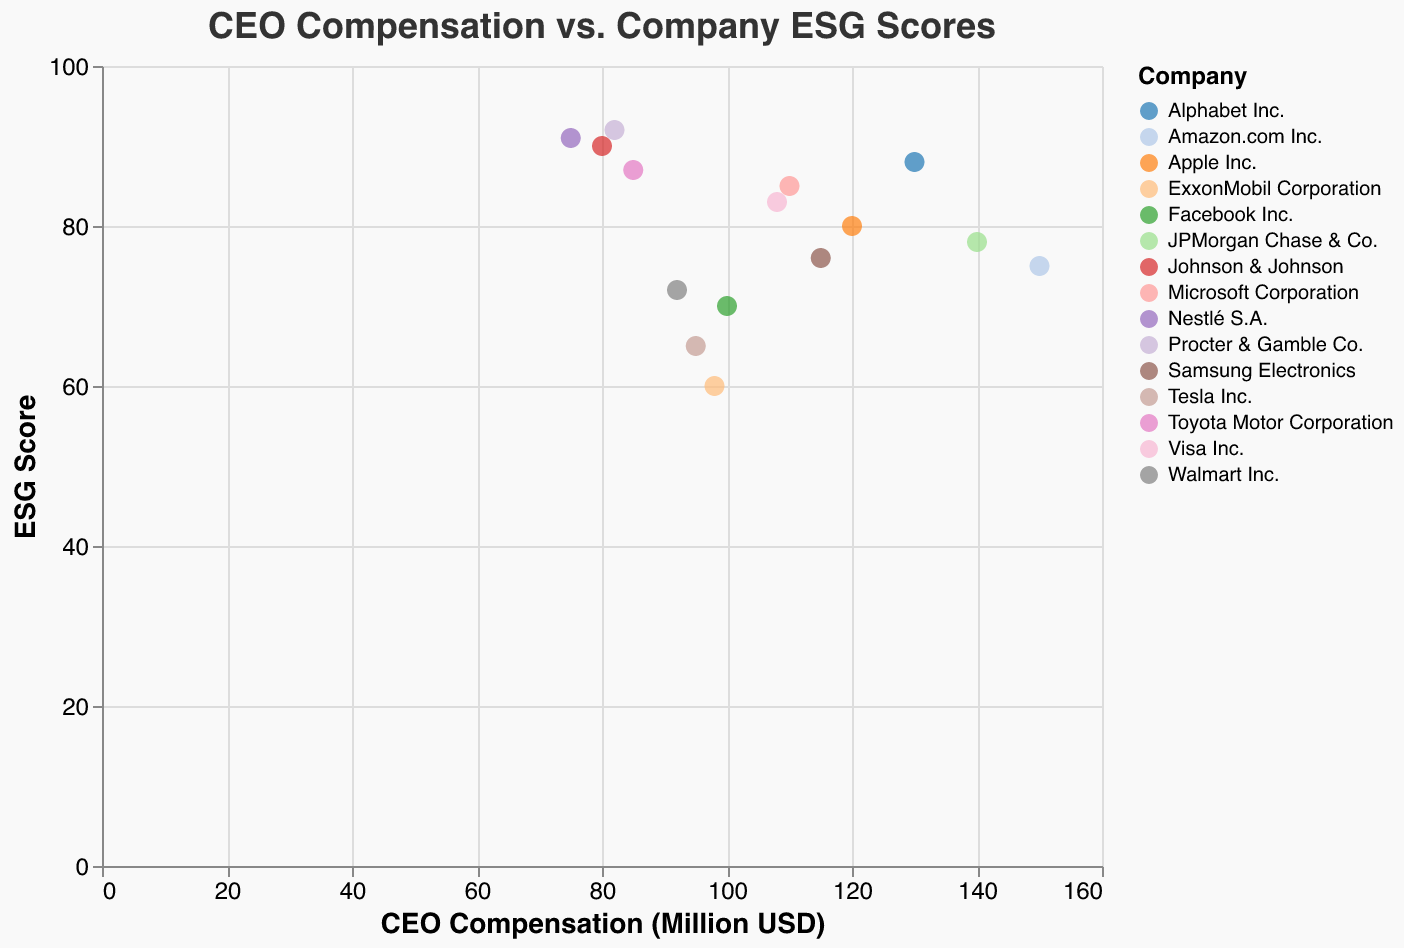What's the title of the plot? The title is usually placed prominently at the top of the plot.
Answer: CEO Compensation vs. Company ESG Scores How many companies are represented in the plot? Each point in the scatter plot represents a different company. Counting all individual points will give the number of companies.
Answer: 15 Which company has the highest CEO compensation? Look for the point farthest to the right on the x-axis, then check the corresponding company label from the tooltip or color legend.
Answer: Amazon.com Inc Which company has the highest ESG Score? Look for the point highest on the y-axis, then check the corresponding company label from the tooltip or color legend.
Answer: Procter & Gamble Co What is the ESG score of the company with the lowest CEO compensation? First, identify the point farthest left on the x-axis (Nestlé S.A.) and then find its corresponding y-axis value.
Answer: 91 What is the average ESG score of the companies with CEO compensation above 100 million USD? Identify companies with compensation above 100 million USD (Apple Inc., Microsoft Corporation, Amazon.com Inc., Alphabet Inc., JPMorgan Chase & Co., Samsung Electronics), calculate their ESG scores' sum (80 + 85 + 75 + 88 + 78 + 76 = 482), and divide by the number of these companies (6).
Answer: 80.3 Which company has a higher CEO compensation: Tesla Inc. or Toyota Motor Corporation? Compare the x-axis values for Tesla Inc. and Toyota Motor Corporation, with Tesla at 95 and Toyota at 85.
Answer: Tesla Inc What is the general trend between CEO compensation and ESG scores based on the given data points? Observing the scatter plot, note whether higher compensation correlates with higher or lower ESG scores. The points appear somewhat scattered, indicating no clear trend.
Answer: No clear trend Which company has an ESG score closest to the median ESG score of all companies? List and arrange the ESG scores in ascending order (60, 65, 70, 72, 75, 76, 78, 80, 83, 85, 87, 88, 90, 91, 92). The median is the 8th score, which is 80, corresponding to Apple Inc.
Answer: Apple Inc How does the environmental focus of Procter & Gamble Co. compare to JPMorgan Chase & Co.? Find the ESG scores for Procter & Gamble Co. and JPMorgan Chase & Co. at 92 and 78, respectively, indicating Procter & Gamble Co. has a higher ESG score.
Answer: HigherESG for Procter & Gamble Co 